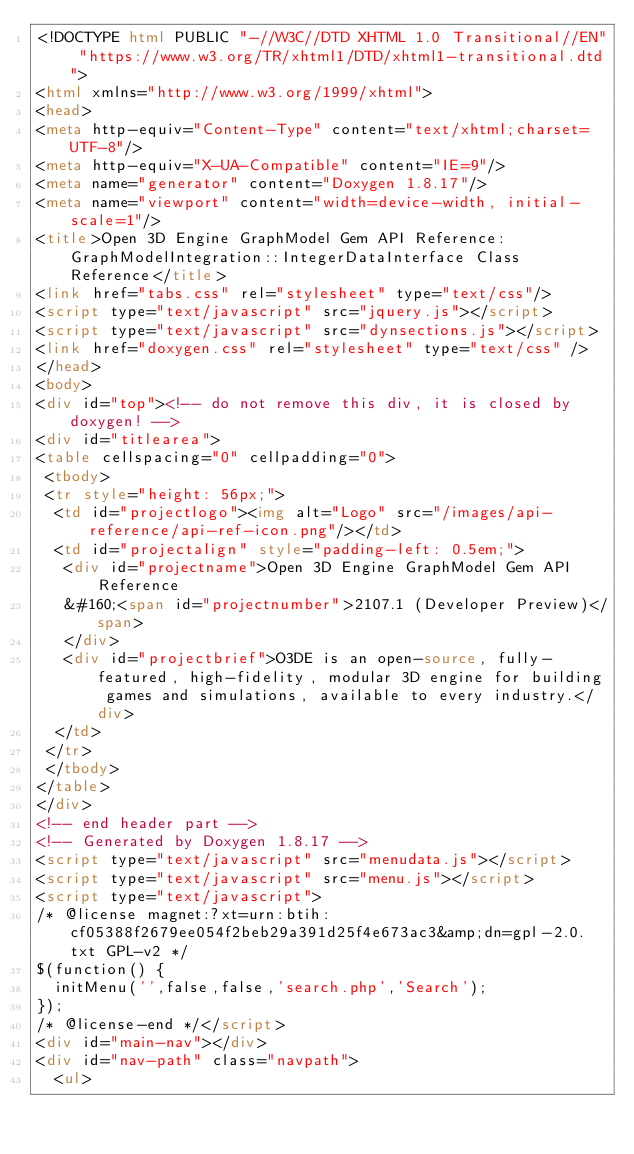<code> <loc_0><loc_0><loc_500><loc_500><_HTML_><!DOCTYPE html PUBLIC "-//W3C//DTD XHTML 1.0 Transitional//EN" "https://www.w3.org/TR/xhtml1/DTD/xhtml1-transitional.dtd">
<html xmlns="http://www.w3.org/1999/xhtml">
<head>
<meta http-equiv="Content-Type" content="text/xhtml;charset=UTF-8"/>
<meta http-equiv="X-UA-Compatible" content="IE=9"/>
<meta name="generator" content="Doxygen 1.8.17"/>
<meta name="viewport" content="width=device-width, initial-scale=1"/>
<title>Open 3D Engine GraphModel Gem API Reference: GraphModelIntegration::IntegerDataInterface Class Reference</title>
<link href="tabs.css" rel="stylesheet" type="text/css"/>
<script type="text/javascript" src="jquery.js"></script>
<script type="text/javascript" src="dynsections.js"></script>
<link href="doxygen.css" rel="stylesheet" type="text/css" />
</head>
<body>
<div id="top"><!-- do not remove this div, it is closed by doxygen! -->
<div id="titlearea">
<table cellspacing="0" cellpadding="0">
 <tbody>
 <tr style="height: 56px;">
  <td id="projectlogo"><img alt="Logo" src="/images/api-reference/api-ref-icon.png"/></td>
  <td id="projectalign" style="padding-left: 0.5em;">
   <div id="projectname">Open 3D Engine GraphModel Gem API Reference
   &#160;<span id="projectnumber">2107.1 (Developer Preview)</span>
   </div>
   <div id="projectbrief">O3DE is an open-source, fully-featured, high-fidelity, modular 3D engine for building games and simulations, available to every industry.</div>
  </td>
 </tr>
 </tbody>
</table>
</div>
<!-- end header part -->
<!-- Generated by Doxygen 1.8.17 -->
<script type="text/javascript" src="menudata.js"></script>
<script type="text/javascript" src="menu.js"></script>
<script type="text/javascript">
/* @license magnet:?xt=urn:btih:cf05388f2679ee054f2beb29a391d25f4e673ac3&amp;dn=gpl-2.0.txt GPL-v2 */
$(function() {
  initMenu('',false,false,'search.php','Search');
});
/* @license-end */</script>
<div id="main-nav"></div>
<div id="nav-path" class="navpath">
  <ul></code> 